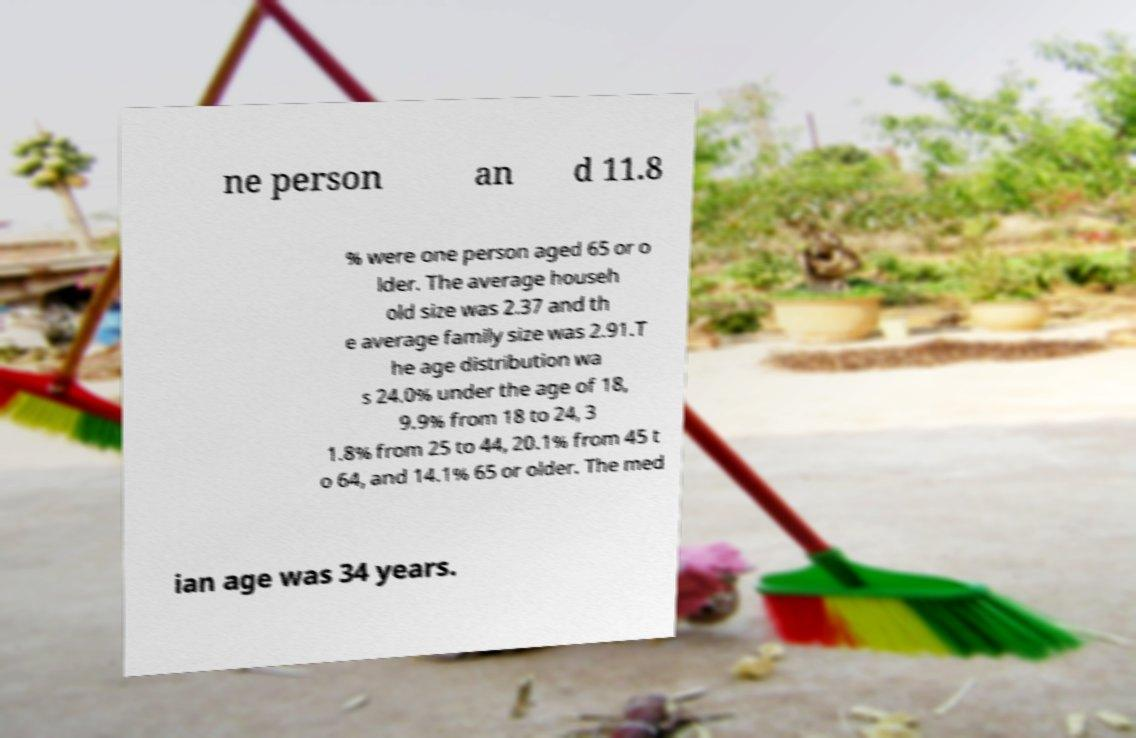I need the written content from this picture converted into text. Can you do that? ne person an d 11.8 % were one person aged 65 or o lder. The average househ old size was 2.37 and th e average family size was 2.91.T he age distribution wa s 24.0% under the age of 18, 9.9% from 18 to 24, 3 1.8% from 25 to 44, 20.1% from 45 t o 64, and 14.1% 65 or older. The med ian age was 34 years. 